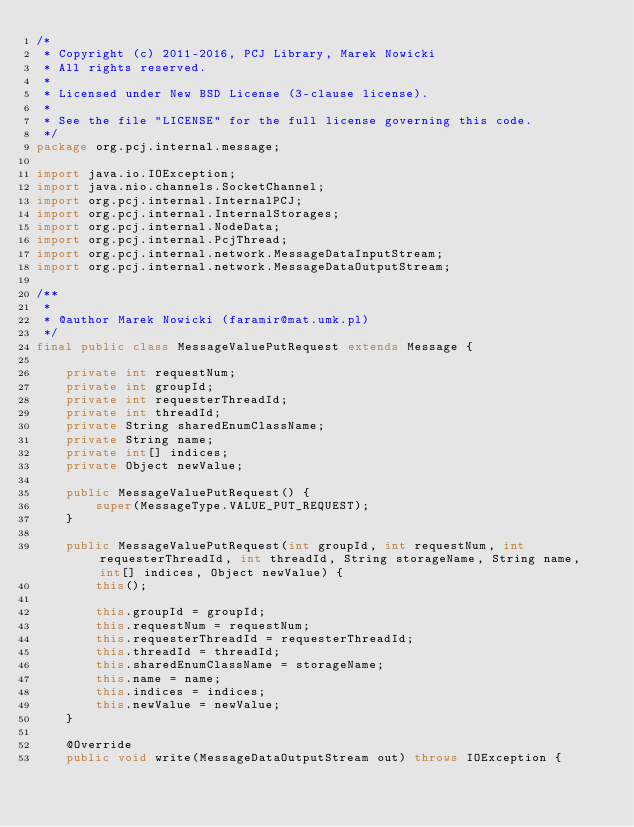<code> <loc_0><loc_0><loc_500><loc_500><_Java_>/* 
 * Copyright (c) 2011-2016, PCJ Library, Marek Nowicki
 * All rights reserved.
 *
 * Licensed under New BSD License (3-clause license).
 *
 * See the file "LICENSE" for the full license governing this code.
 */
package org.pcj.internal.message;

import java.io.IOException;
import java.nio.channels.SocketChannel;
import org.pcj.internal.InternalPCJ;
import org.pcj.internal.InternalStorages;
import org.pcj.internal.NodeData;
import org.pcj.internal.PcjThread;
import org.pcj.internal.network.MessageDataInputStream;
import org.pcj.internal.network.MessageDataOutputStream;

/**
 *
 * @author Marek Nowicki (faramir@mat.umk.pl)
 */
final public class MessageValuePutRequest extends Message {

    private int requestNum;
    private int groupId;
    private int requesterThreadId;
    private int threadId;
    private String sharedEnumClassName;
    private String name;
    private int[] indices;
    private Object newValue;

    public MessageValuePutRequest() {
        super(MessageType.VALUE_PUT_REQUEST);
    }

    public MessageValuePutRequest(int groupId, int requestNum, int requesterThreadId, int threadId, String storageName, String name, int[] indices, Object newValue) {
        this();

        this.groupId = groupId;
        this.requestNum = requestNum;
        this.requesterThreadId = requesterThreadId;
        this.threadId = threadId;
        this.sharedEnumClassName = storageName;
        this.name = name;
        this.indices = indices;
        this.newValue = newValue;
    }

    @Override
    public void write(MessageDataOutputStream out) throws IOException {</code> 